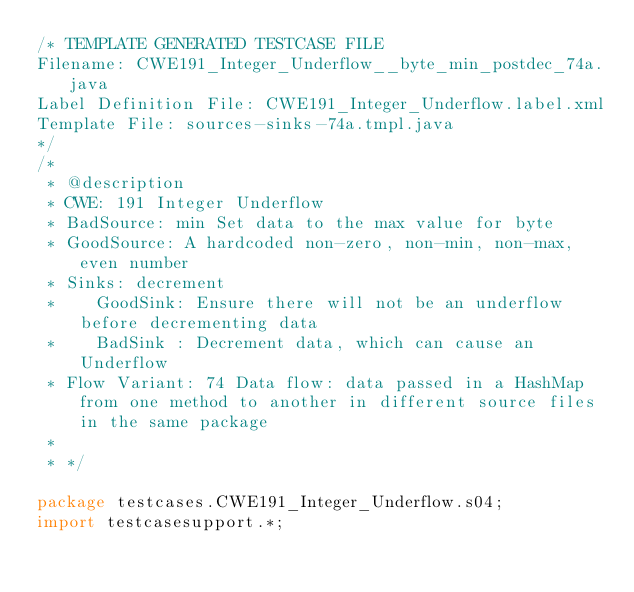<code> <loc_0><loc_0><loc_500><loc_500><_Java_>/* TEMPLATE GENERATED TESTCASE FILE
Filename: CWE191_Integer_Underflow__byte_min_postdec_74a.java
Label Definition File: CWE191_Integer_Underflow.label.xml
Template File: sources-sinks-74a.tmpl.java
*/
/*
 * @description
 * CWE: 191 Integer Underflow
 * BadSource: min Set data to the max value for byte
 * GoodSource: A hardcoded non-zero, non-min, non-max, even number
 * Sinks: decrement
 *    GoodSink: Ensure there will not be an underflow before decrementing data
 *    BadSink : Decrement data, which can cause an Underflow
 * Flow Variant: 74 Data flow: data passed in a HashMap from one method to another in different source files in the same package
 *
 * */

package testcases.CWE191_Integer_Underflow.s04;
import testcasesupport.*;</code> 